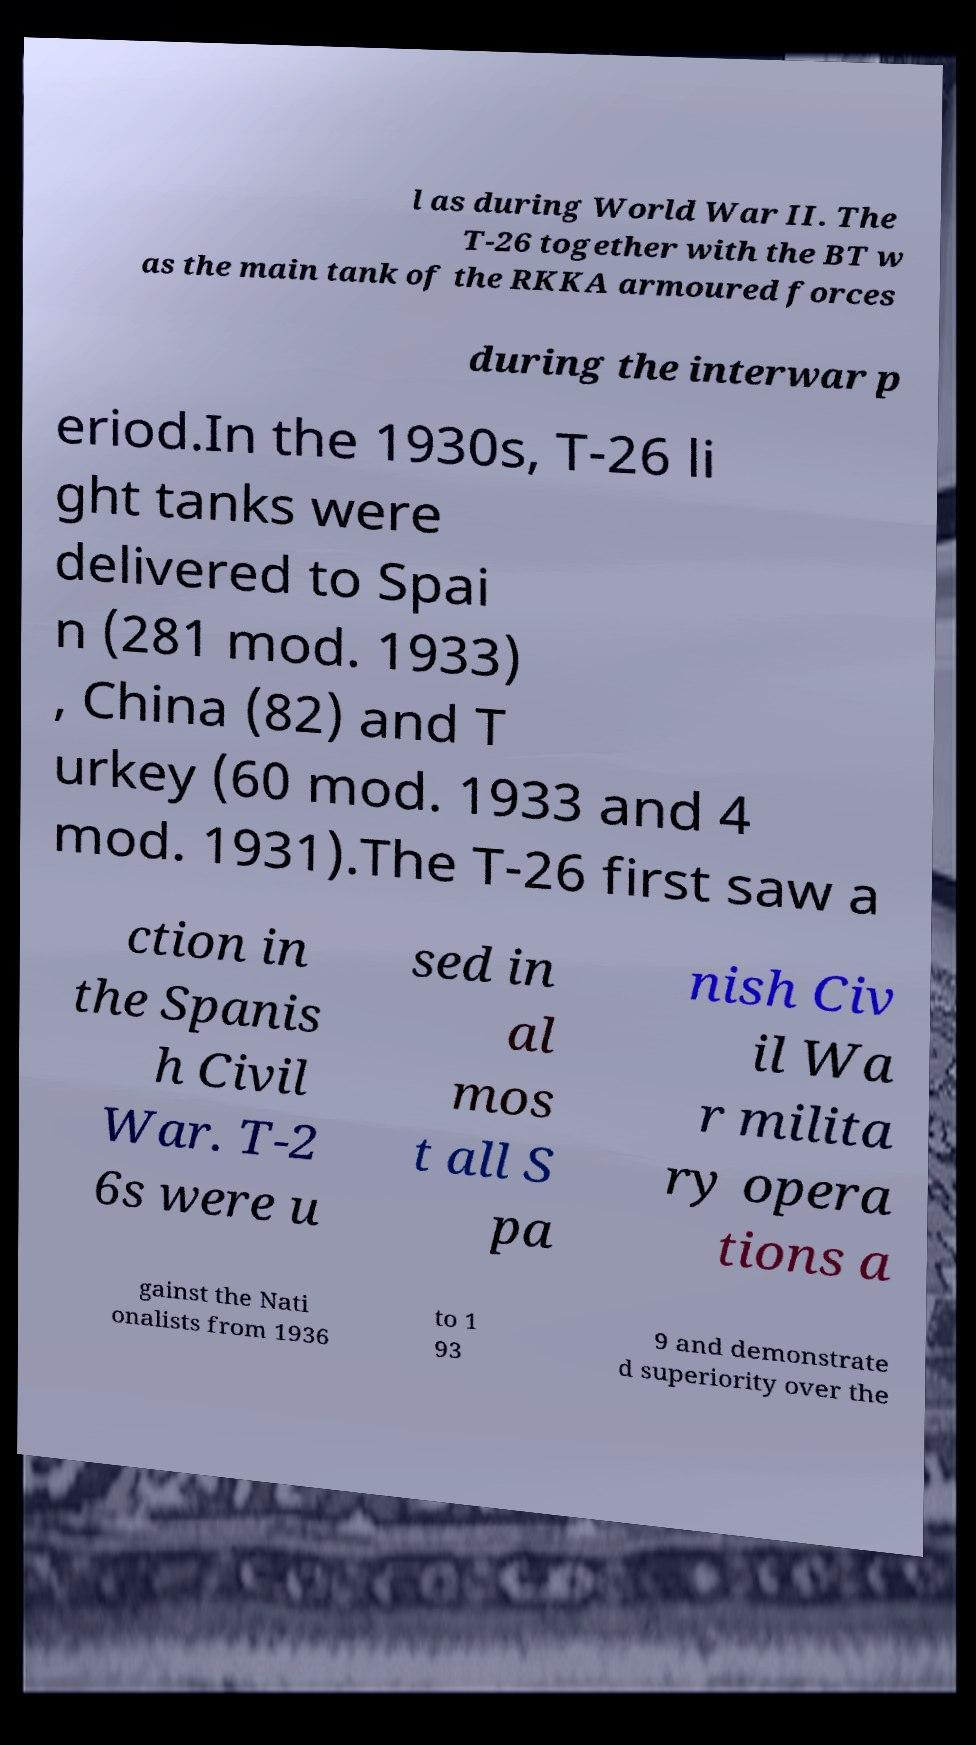Could you extract and type out the text from this image? l as during World War II. The T-26 together with the BT w as the main tank of the RKKA armoured forces during the interwar p eriod.In the 1930s, T-26 li ght tanks were delivered to Spai n (281 mod. 1933) , China (82) and T urkey (60 mod. 1933 and 4 mod. 1931).The T-26 first saw a ction in the Spanis h Civil War. T-2 6s were u sed in al mos t all S pa nish Civ il Wa r milita ry opera tions a gainst the Nati onalists from 1936 to 1 93 9 and demonstrate d superiority over the 